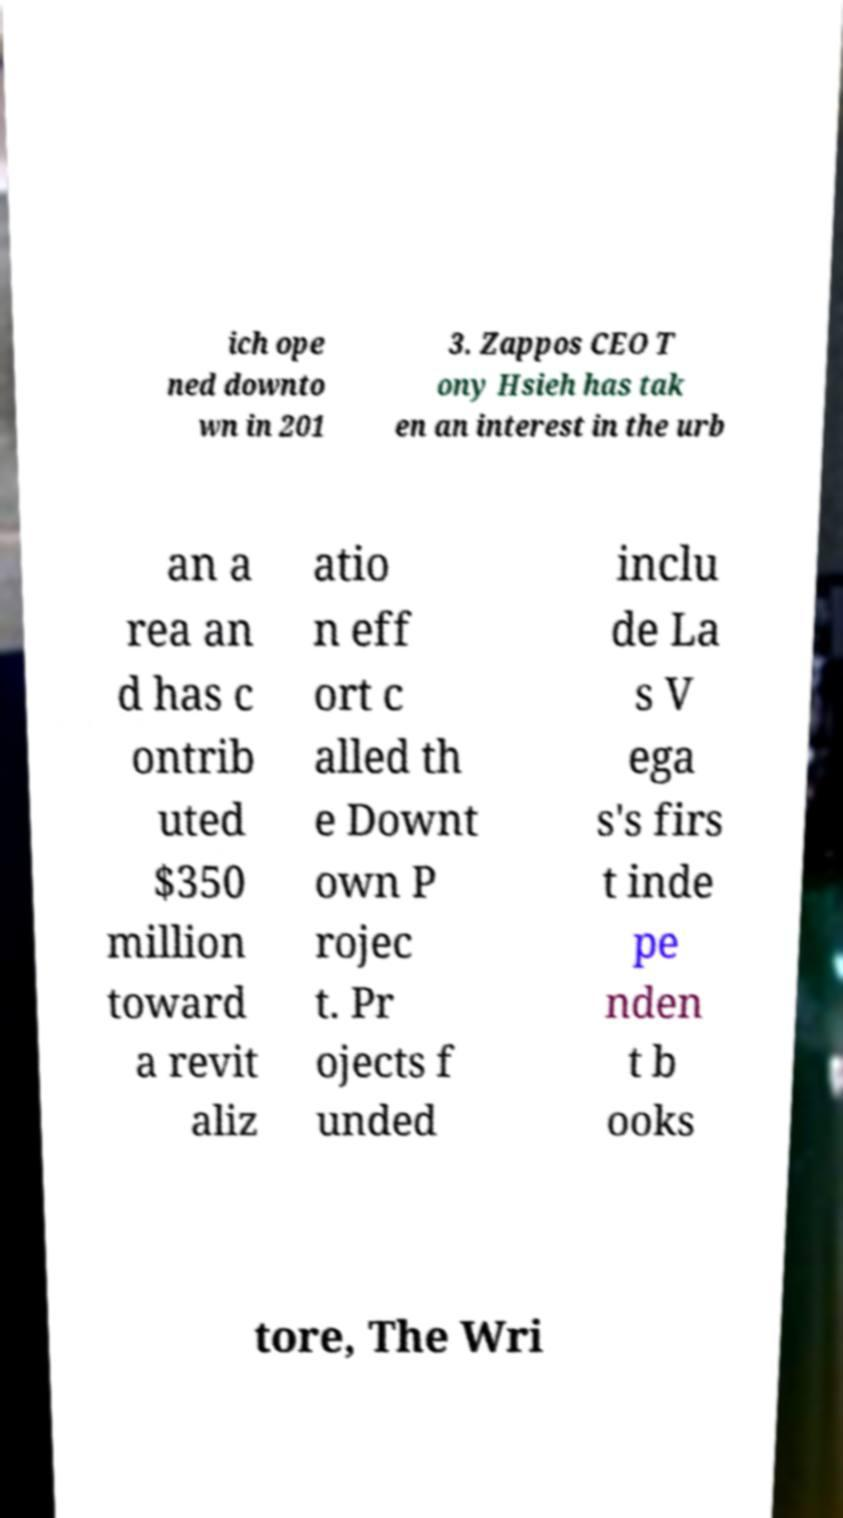Can you accurately transcribe the text from the provided image for me? ich ope ned downto wn in 201 3. Zappos CEO T ony Hsieh has tak en an interest in the urb an a rea an d has c ontrib uted $350 million toward a revit aliz atio n eff ort c alled th e Downt own P rojec t. Pr ojects f unded inclu de La s V ega s's firs t inde pe nden t b ooks tore, The Wri 